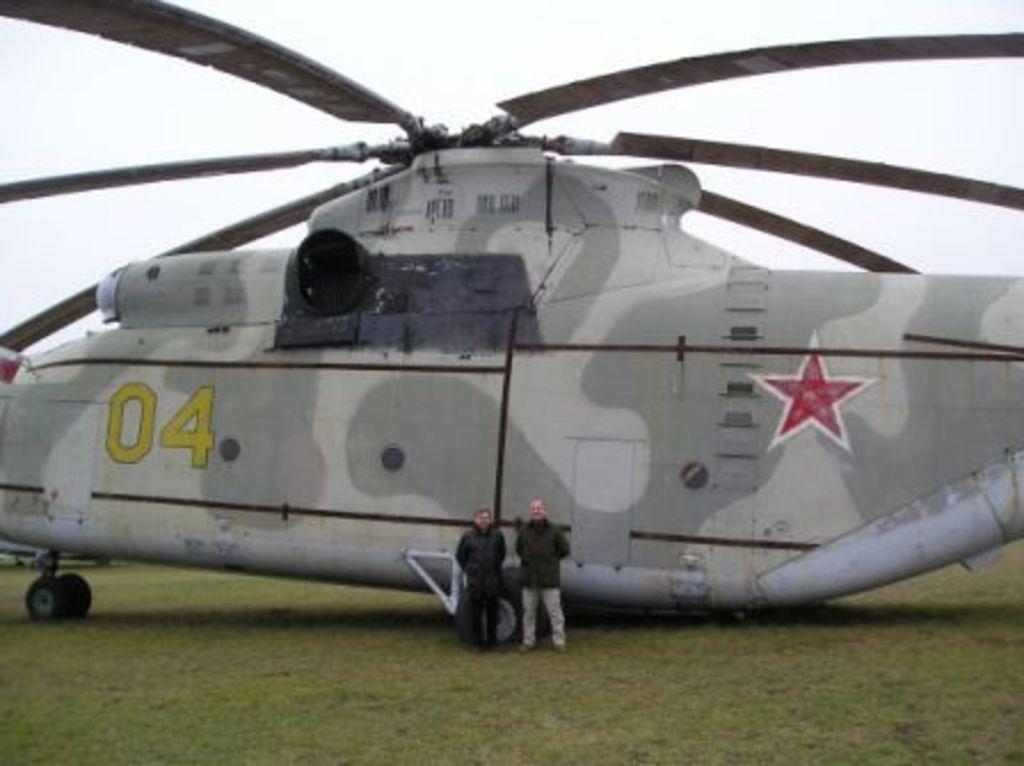What numbers identify this plane?
Your response must be concise. 04. 